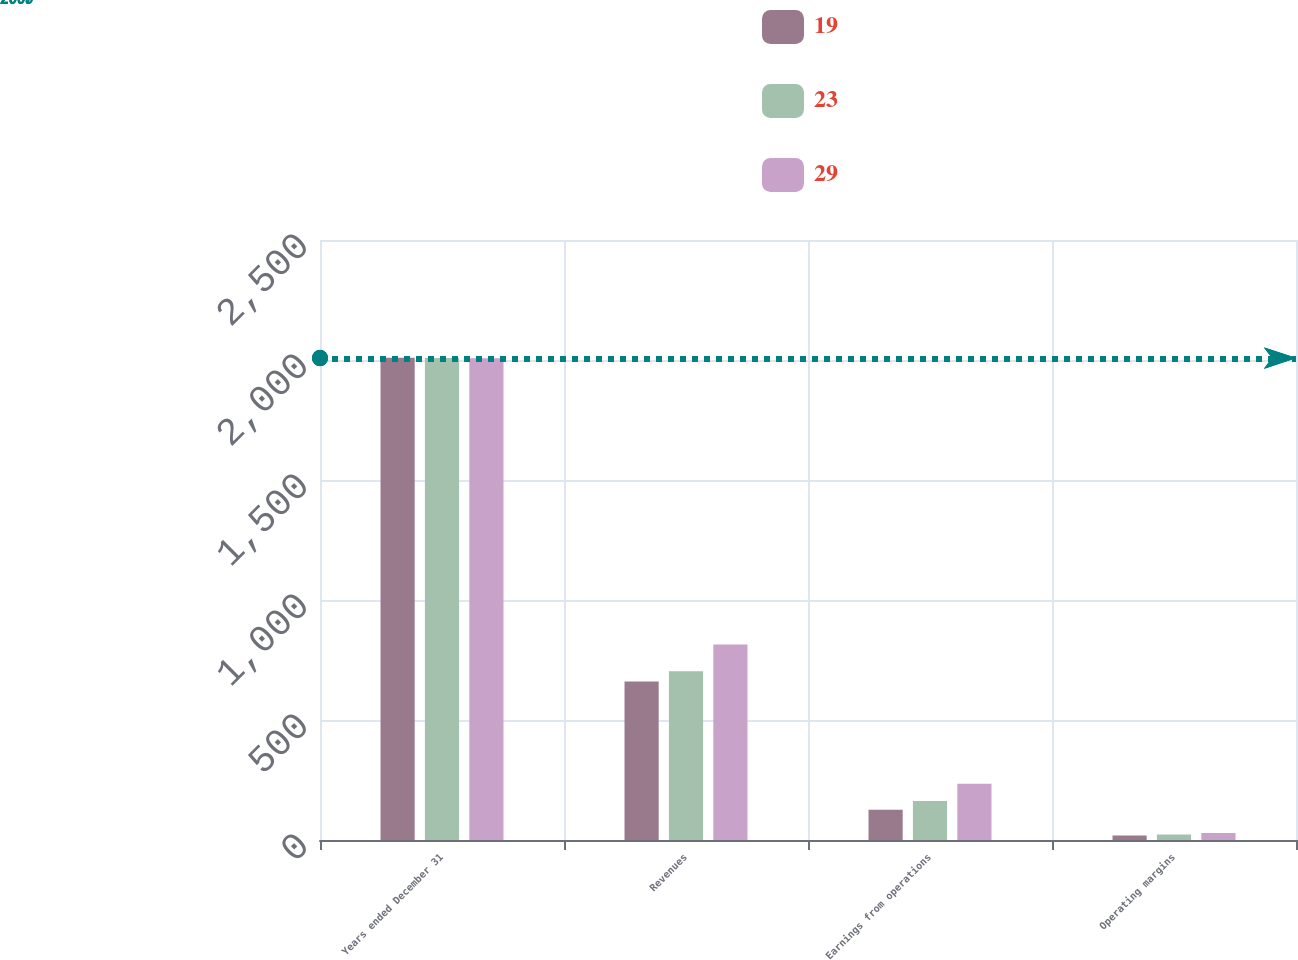Convert chart to OTSL. <chart><loc_0><loc_0><loc_500><loc_500><stacked_bar_chart><ecel><fcel>Years ended December 31<fcel>Revenues<fcel>Earnings from operations<fcel>Operating margins<nl><fcel>19<fcel>2009<fcel>660<fcel>126<fcel>19<nl><fcel>23<fcel>2008<fcel>703<fcel>162<fcel>23<nl><fcel>29<fcel>2007<fcel>815<fcel>234<fcel>29<nl></chart> 